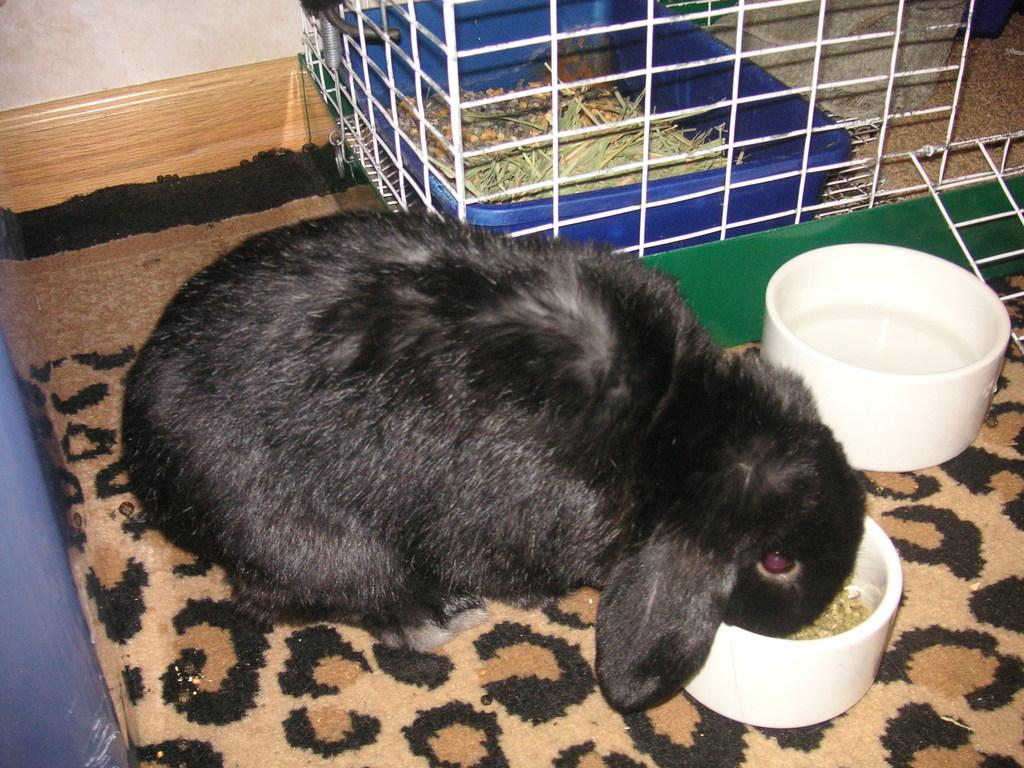What animal is present in the image? There is a black rabbit in the image. What is the rabbit doing in the image? The rabbit is having food in a bowl. What type of flooring is visible in the image? There is a carpet in the image. What structure is present in the image that contains the rabbit? There is a cage in the image, and the rabbit is inside it. What is inside the cage with the rabbit? The cage contains a tray with dry grass inside it. Where is the cage located in the image? The cage is in front of a wall. What type of stove is visible in the image? There is no stove present in the image. Can you describe the waves in the image? There are no waves present in the image. 